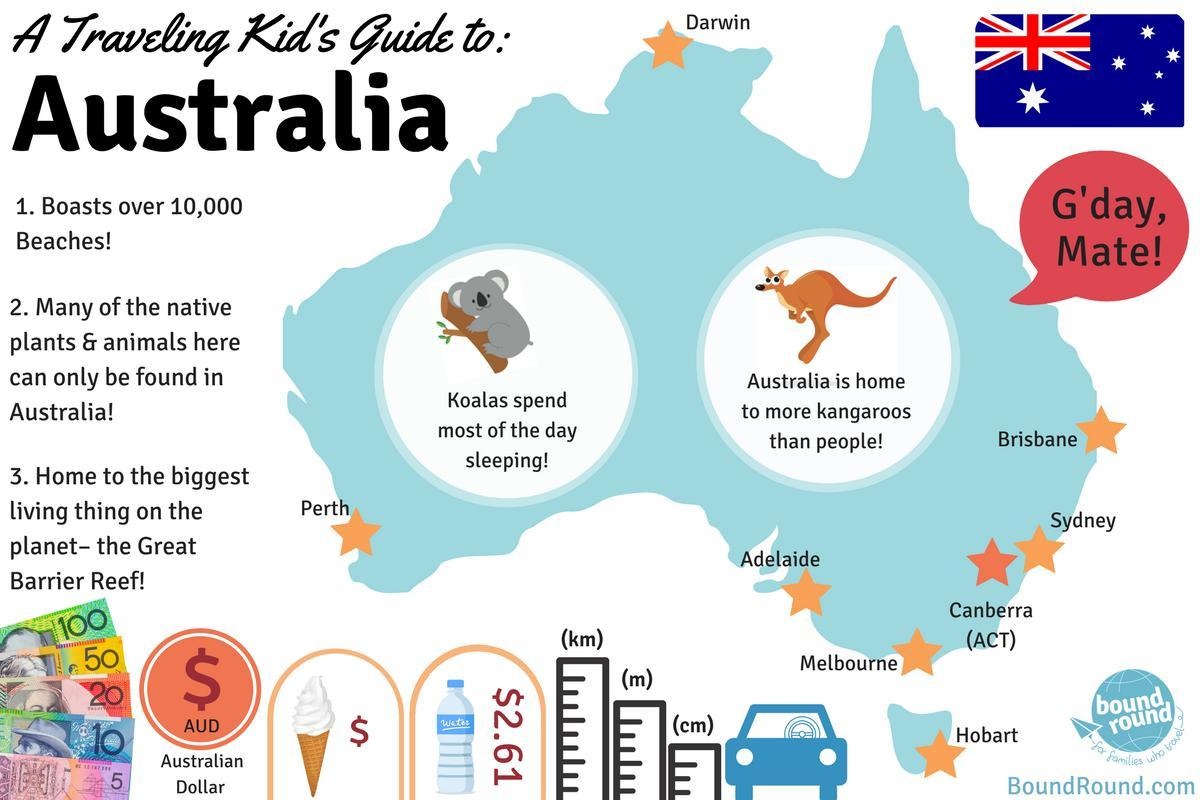What is the average cost of bottled water in Australia per litre?
Answer the question with a short phrase. $2.61 Which is the national animal of Australia? kangaroo Which city is marked in the north Darwin which is the city marked on the south-west coast Perth Which city is marked on the island Hobart 